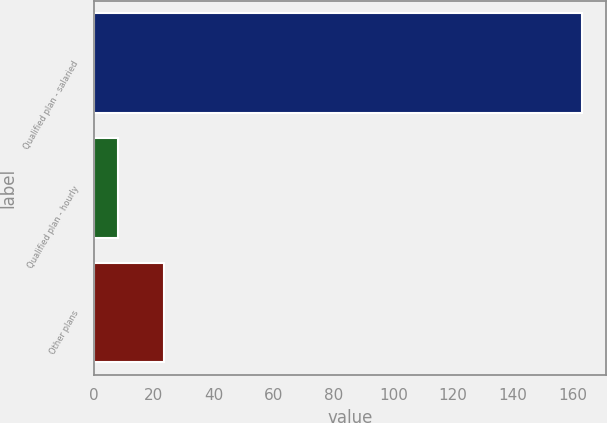Convert chart. <chart><loc_0><loc_0><loc_500><loc_500><bar_chart><fcel>Qualified plan - salaried<fcel>Qualified plan - hourly<fcel>Other plans<nl><fcel>163<fcel>8<fcel>23.5<nl></chart> 